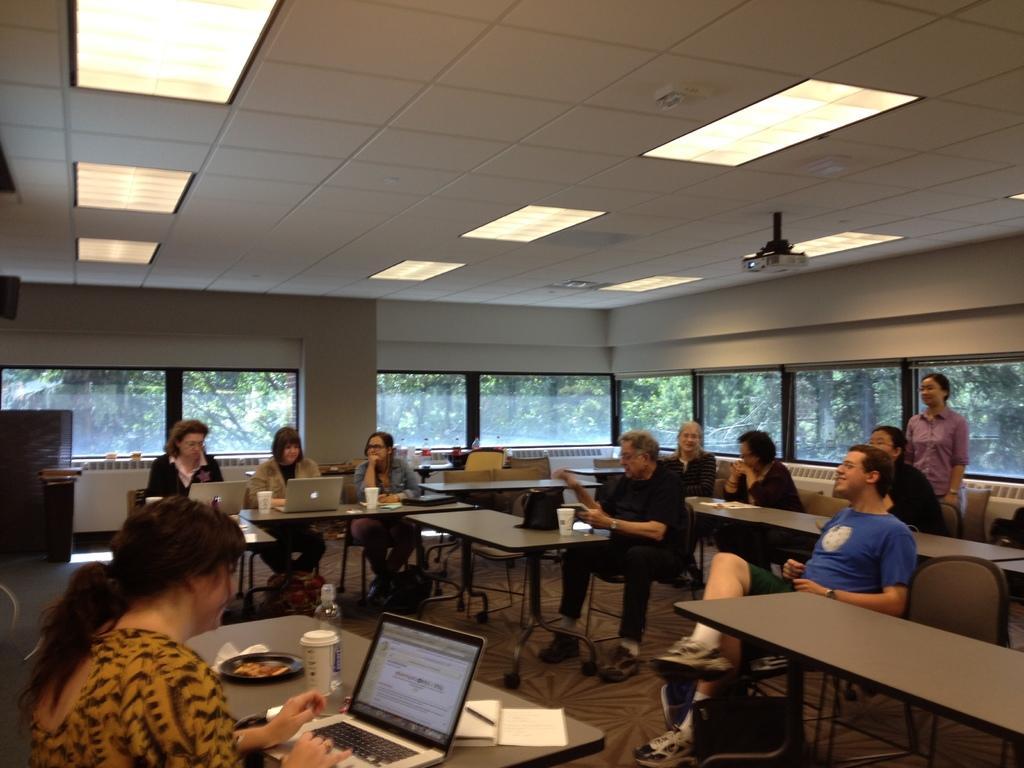In one or two sentences, can you explain what this image depicts? There are group of people sitting on the chairs. This is a table with laptops,tumblers,and plates placed on it. This is a projector attached to the rooftop. This is a ceiling lights. These are the windows,I can see trees through the window. 